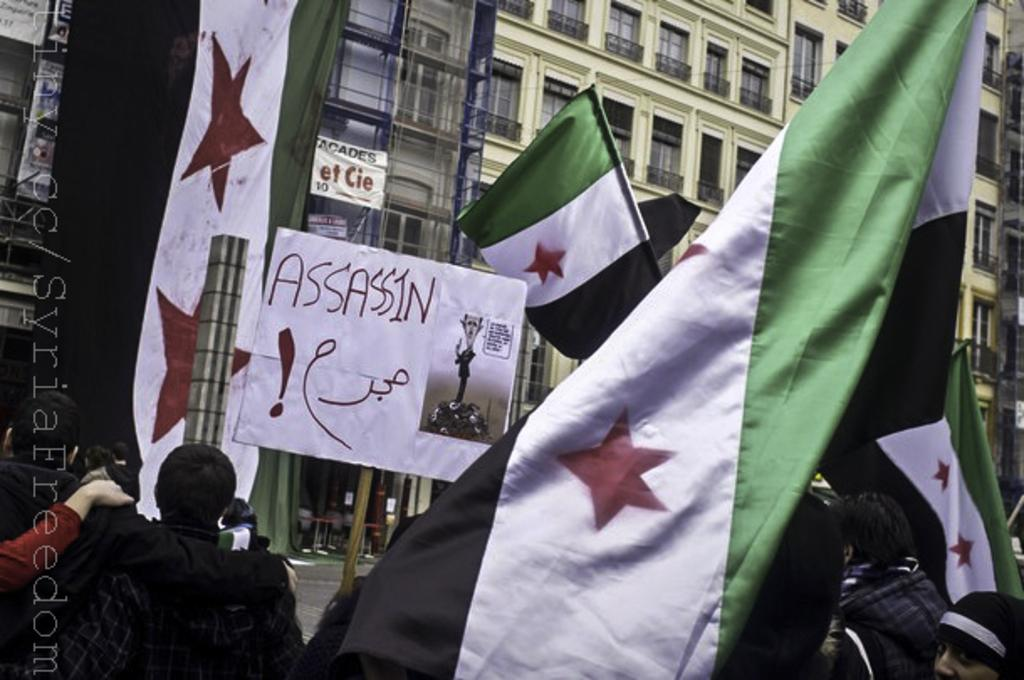What are the people in the image holding? The people in the image are holding flags and hoardings. What can be seen in the background of the image? In the background of the image, there is a building with windows, fences, a banner, and other items visible. Can you describe the building in the background? The building in the background has windows and is surrounded by fences. There is also a banner and other items visible. What type of health advice can be seen on the banner in the image? There is no health advice visible on the banner in the image. What time of day is it in the image, given the presence of fairies? There are no fairies present in the image, so it is not possible to determine the time of day based on their presence. 